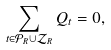Convert formula to latex. <formula><loc_0><loc_0><loc_500><loc_500>\sum _ { t \in \mathcal { P } _ { R } \cup \mathcal { Z } _ { R } } Q _ { t } = 0 ,</formula> 